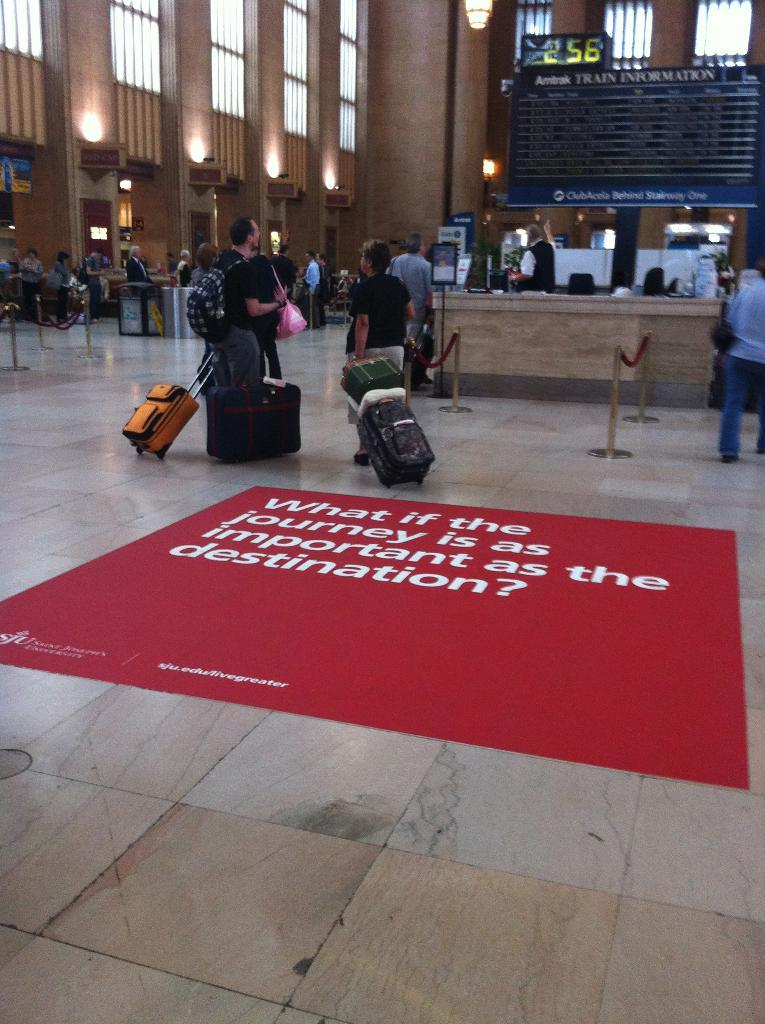Where was the image taken? The image was taken at an airport. What are the people in the image doing? There are people with their luggage in the image, which suggests they are either arriving or departing. What can be seen on the red-colored mat in the image? The phrase "what if the journey is as important as the destination" is written on the mat. How many pairs of scissors are visible in the image? There are no scissors present in the image. Can you see any rabbits in the image? There are no rabbits present in the image. 